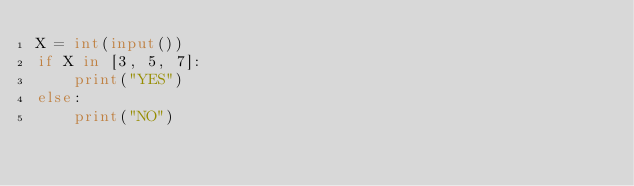<code> <loc_0><loc_0><loc_500><loc_500><_Python_>X = int(input())
if X in [3, 5, 7]:
    print("YES")
else:
    print("NO")
</code> 